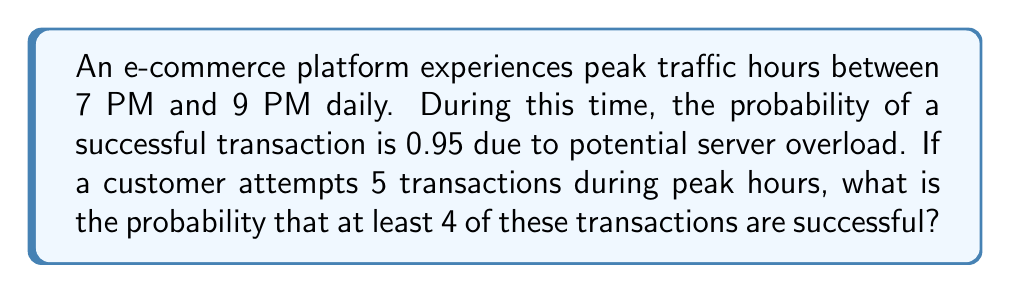Can you answer this question? Let's approach this step-by-step using the binomial probability distribution:

1) We can model this scenario as a binomial distribution with the following parameters:
   $n = 5$ (number of trials)
   $p = 0.95$ (probability of success for each trial)
   $X$ = number of successful transactions

2) We need to find $P(X \geq 4)$, which is equivalent to $1 - P(X < 4)$ or $1 - P(X \leq 3)$

3) Using the binomial probability formula:
   $$P(X = k) = \binom{n}{k} p^k (1-p)^{n-k}$$

4) We need to calculate:
   $$P(X \geq 4) = 1 - [P(X = 0) + P(X = 1) + P(X = 2) + P(X = 3)]$$

5) Let's calculate each term:
   
   $P(X = 3) = \binom{5}{3} (0.95)^3 (0.05)^2 = 10 \cdot 0.857375 \cdot 0.0025 = 0.021434375$
   
   $P(X = 2) = \binom{5}{2} (0.95)^2 (0.05)^3 = 10 \cdot 0.9025 \cdot 0.000125 = 0.00112812$
   
   $P(X = 1) = \binom{5}{1} (0.95)^1 (0.05)^4 = 5 \cdot 0.95 \cdot 0.00000625 = 0.0000297$
   
   $P(X = 0) = \binom{5}{0} (0.95)^0 (0.05)^5 = 1 \cdot 1 \cdot 0.0000000003125 = 0.0000000003125$

6) Sum these probabilities and subtract from 1:
   $$1 - (0.021434375 + 0.00112812 + 0.0000297 + 0.0000000003125) = 0.977407505$$

Therefore, the probability of at least 4 successful transactions out of 5 during peak hours is approximately 0.9774 or 97.74%.
Answer: 0.9774 